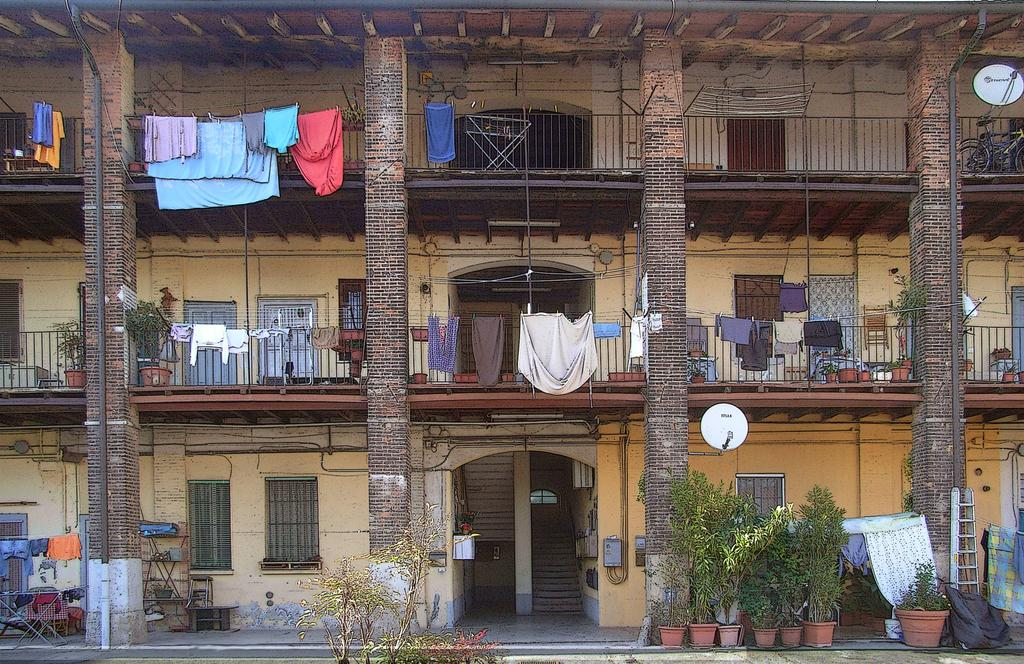What type of structure is in the image? There is a building in the image. What can be seen hanging outside the building? Clothes are hanged on ropes in the image. What is used for cooking in the image? Grills are present in the image. What are the sources of electricity in the image? Electric lights and electric shafts are in the image. How can people enter or exit the building? Doors are present in the image. How can natural light enter the building? Windows are visible in the image. What type of plants are inside the building? Houseplants are in the image. What is used for climbing or reaching higher areas in the image? A ladder is present in the image. What type of transportation is in the image? Bicycles are in the image. What devices are used for receiving signals in the image? Antennas are visible in the image. What type of rod is used for stirring the soup in the image? There is no soup or rod present in the image. What decision was made by the person in the image? There is no person in the image, so no decision can be attributed to anyone. 